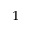Convert formula to latex. <formula><loc_0><loc_0><loc_500><loc_500>^ { 1 }</formula> 